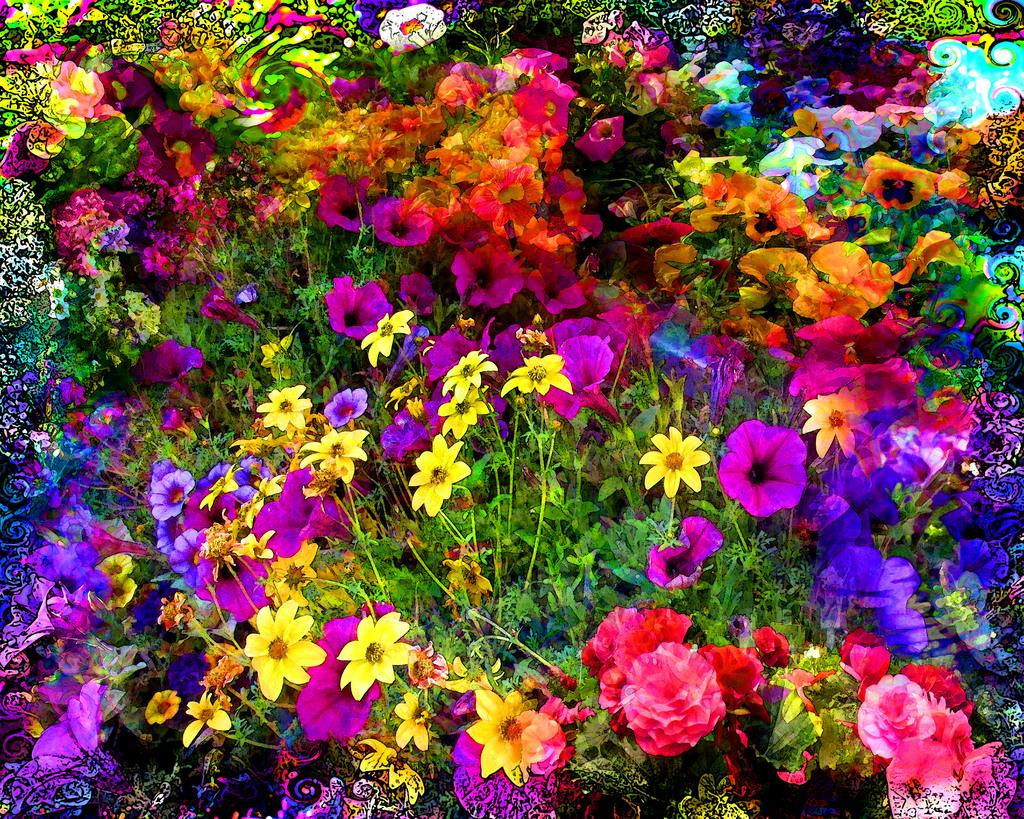What is the main subject of the image? The main subject of the image is a group of plants. What can be observed about the plants in the image? The plants have flowers. What colors are the flowers? The flowers are red, pink, yellow, violet, and blue in color. What type of ice can be seen melting on the leaves of the plants in the image? There is no ice present on the leaves of the plants in the image. How many pails of butter are visible in the image? There are no pails of butter present in the image. 